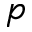Convert formula to latex. <formula><loc_0><loc_0><loc_500><loc_500>p</formula> 